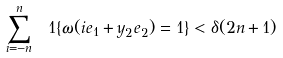Convert formula to latex. <formula><loc_0><loc_0><loc_500><loc_500>\sum _ { i = - n } ^ { n } \ 1 { \{ \omega ( i e _ { 1 } + y _ { 2 } e _ { 2 } ) = 1 \} } < \delta ( 2 n + 1 )</formula> 